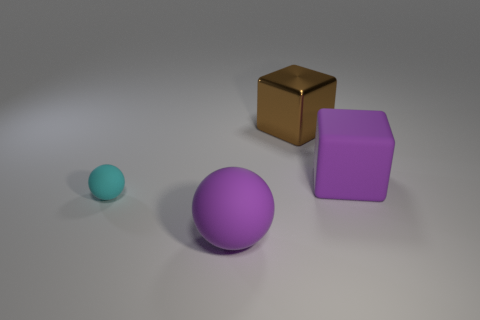Are there any other things that are the same material as the brown block?
Offer a terse response. No. How many things are left of the purple matte ball and behind the big purple cube?
Make the answer very short. 0. How many rubber objects are big blue spheres or purple cubes?
Your answer should be very brief. 1. There is a cyan matte sphere to the left of the purple matte object that is right of the brown thing; what is its size?
Offer a terse response. Small. There is a big sphere that is the same color as the matte block; what material is it?
Offer a very short reply. Rubber. There is a brown thing that is behind the large object that is to the left of the big metal cube; are there any tiny rubber things on the right side of it?
Keep it short and to the point. No. Do the object that is to the left of the big purple rubber ball and the ball that is in front of the cyan matte thing have the same material?
Your answer should be compact. Yes. What number of objects are either red metallic cubes or objects on the right side of the cyan thing?
Your response must be concise. 3. What number of big purple objects have the same shape as the small cyan object?
Ensure brevity in your answer.  1. What is the material of the purple block that is the same size as the brown thing?
Make the answer very short. Rubber. 